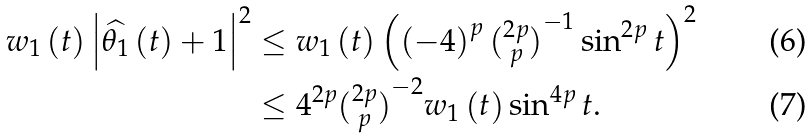<formula> <loc_0><loc_0><loc_500><loc_500>w _ { 1 } \left ( t \right ) \left | \widehat { \theta _ { 1 } } \left ( t \right ) + 1 \right | ^ { 2 } & \leq w _ { 1 } \left ( t \right ) \left ( \left ( - 4 \right ) ^ { p } \tbinom { 2 p } { p } ^ { - 1 } \sin ^ { 2 p } t \right ) ^ { 2 } \\ & \leq 4 ^ { 2 p } \tbinom { 2 p } { p } ^ { - 2 } w _ { 1 } \left ( t \right ) \sin ^ { 4 p } t .</formula> 